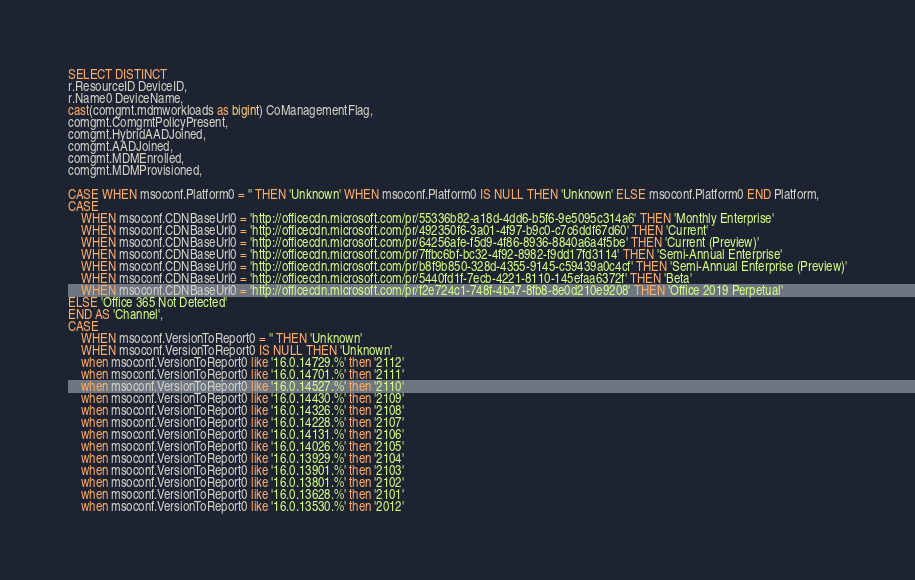<code> <loc_0><loc_0><loc_500><loc_500><_SQL_>SELECT DISTINCT
r.ResourceID DeviceID,
r.Name0 DeviceName,
cast(comgmt.mdmworkloads as bigint) CoManagementFlag,
comgmt.ComgmtPolicyPresent,
comgmt.HybridAADJoined,
comgmt.AADJoined,
comgmt.MDMEnrolled,
comgmt.MDMProvisioned,

CASE WHEN msoconf.Platform0 = '' THEN 'Unknown' WHEN msoconf.Platform0 IS NULL THEN 'Unknown' ELSE msoconf.Platform0 END Platform,
CASE 
	WHEN msoconf.CDNBaseUrl0 = 'http://officecdn.microsoft.com/pr/55336b82-a18d-4dd6-b5f6-9e5095c314a6' THEN 'Monthly Enterprise'
	WHEN msoconf.CDNBaseUrl0 = 'http://officecdn.microsoft.com/pr/492350f6-3a01-4f97-b9c0-c7c6ddf67d60' THEN 'Current'
	WHEN msoconf.CDNBaseUrl0 = 'http://officecdn.microsoft.com/pr/64256afe-f5d9-4f86-8936-8840a6a4f5be' THEN 'Current (Preview)'
	WHEN msoconf.CDNBaseUrl0 = 'http://officecdn.microsoft.com/pr/7ffbc6bf-bc32-4f92-8982-f9dd17fd3114' THEN 'Semi-Annual Enterprise'
	WHEN msoconf.CDNBaseUrl0 = 'http://officecdn.microsoft.com/pr/b8f9b850-328d-4355-9145-c59439a0c4cf' THEN 'Semi-Annual Enterprise (Preview)'
	WHEN msoconf.CDNBaseUrl0 = 'http://officecdn.microsoft.com/pr/5440fd1f-7ecb-4221-8110-145efaa6372f' THEN 'Beta'
	WHEN msoconf.CDNBaseUrl0 = 'http://officecdn.microsoft.com/pr/f2e724c1-748f-4b47-8fb8-8e0d210e9208' THEN 'Office 2019 Perpetual'
ELSE 'Office 365 Not Detected'
END AS 'Channel',
CASE 
	WHEN msoconf.VersionToReport0 = '' THEN 'Unknown'
	WHEN msoconf.VersionToReport0 IS NULL THEN 'Unknown' 
	when msoconf.VersionToReport0 like '16.0.14729.%' then '2112'
	when msoconf.VersionToReport0 like '16.0.14701.%' then '2111'
	when msoconf.VersionToReport0 like '16.0.14527.%' then '2110'
	when msoconf.VersionToReport0 like '16.0.14430.%' then '2109'
	when msoconf.VersionToReport0 like '16.0.14326.%' then '2108'
	when msoconf.VersionToReport0 like '16.0.14228.%' then '2107'
	when msoconf.VersionToReport0 like '16.0.14131.%' then '2106'
	when msoconf.VersionToReport0 like '16.0.14026.%' then '2105'
	when msoconf.VersionToReport0 like '16.0.13929.%' then '2104'
	when msoconf.VersionToReport0 like '16.0.13901.%' then '2103'
	when msoconf.VersionToReport0 like '16.0.13801.%' then '2102'
	when msoconf.VersionToReport0 like '16.0.13628.%' then '2101'
	when msoconf.VersionToReport0 like '16.0.13530.%' then '2012'</code> 